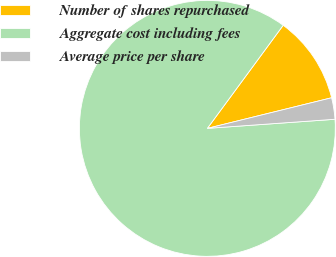Convert chart. <chart><loc_0><loc_0><loc_500><loc_500><pie_chart><fcel>Number of shares repurchased<fcel>Aggregate cost including fees<fcel>Average price per share<nl><fcel>11.06%<fcel>86.22%<fcel>2.71%<nl></chart> 